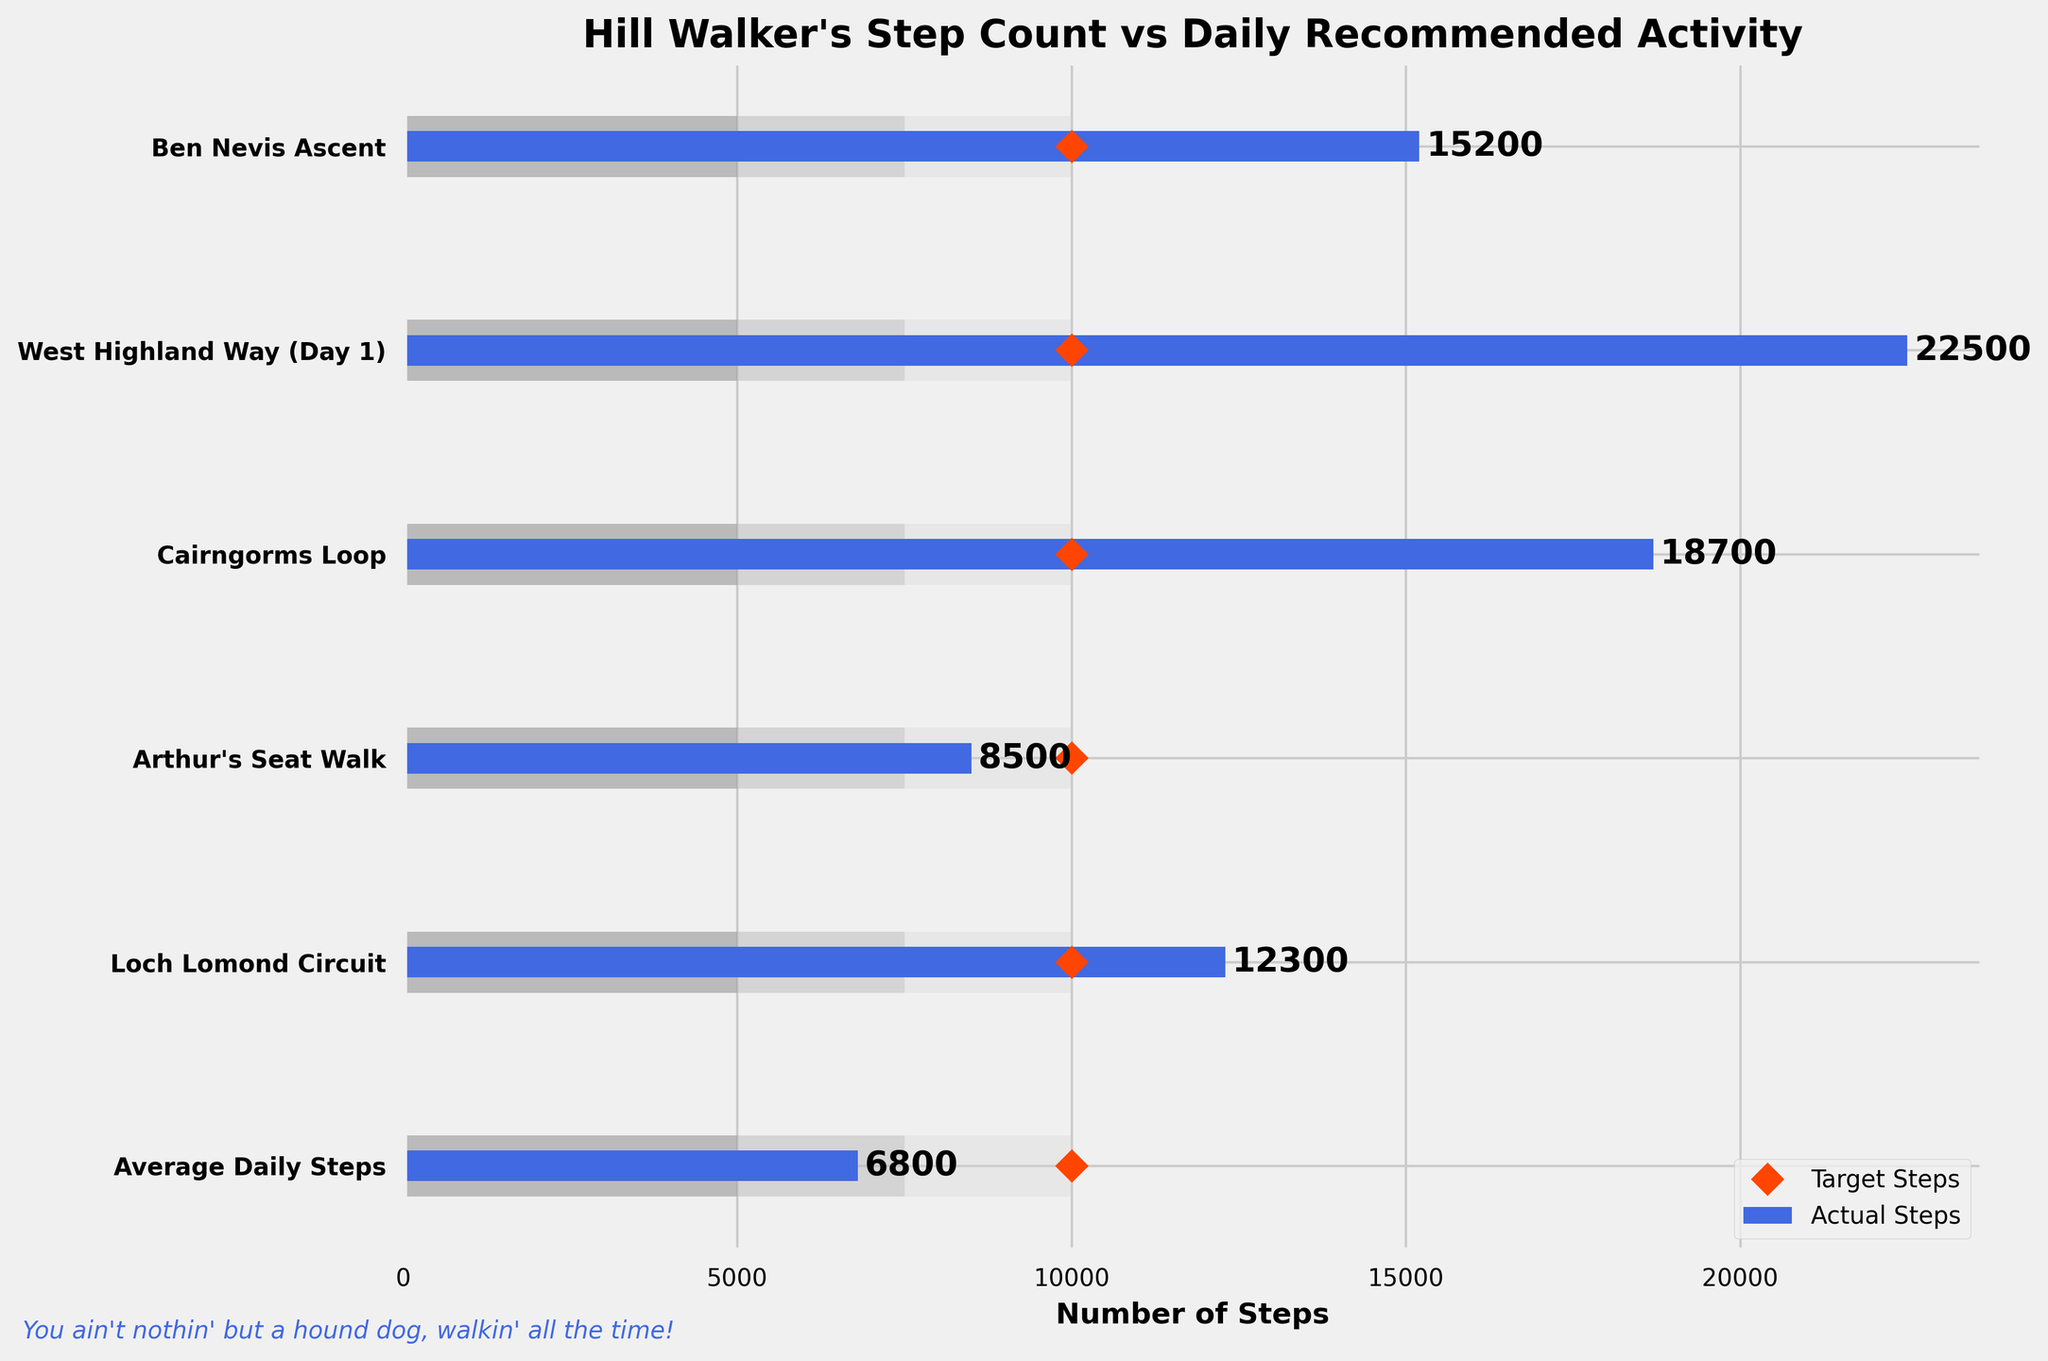What's the title of the figure? The title of the graph is typically at the top of the figure, displayed prominently in a larger and bold font for easy visibility. In this case, it is clearly written as "Hill Walker's Step Count vs Daily Recommended Activity".
Answer: Hill Walker's Step Count vs Daily Recommended Activity How many walks are compared in the figure? Each row in the figure represents a different walk or data point. We can count the number of rows to determine how many walks are included. Here, the figure has 6 rows corresponding to different walks.
Answer: 6 Which walk recorded the highest number of steps? By comparing the lengths of the blue bars (Actual Steps) across all walks, the walk with the longest blue bar represents the highest number of steps. "West Highland Way (Day 1)" has the longest blue bar.
Answer: West Highland Way (Day 1) Did "Arthur's Seat Walk" meet the target steps? To determine if the actual steps meet the target, we compare the length of the blue bar (Actual Steps) with the position of the orange diamond (Target Steps). For "Arthur's Seat Walk," the blue bar is shorter than the orange diamond, meaning it did not meet the target.
Answer: No How many walks exceeded the daily recommended target of 10,000 steps? We count the number of walks where the blue bar exceeds the position of the orange diamond. "Ben Nevis Ascent," "West Highland Way (Day 1)," "Cairngorms Loop," and "Loch Lomond Circuit" all exceed the target.
Answer: 4 What is the difference in steps between the "Ben Nevis Ascent" and the "Average Daily Steps"? Subtract the number of steps for "Average Daily Steps" from the number for "Ben Nevis Ascent": 15200 - 6800. Performing this calculation gives 8400 steps.
Answer: 8400 steps Which walk is closest to the target steps but still below it? To find the walk closest to the target but below it, look at the blue bars just shorter than the orange diamonds and identify the one with the smallest difference. "Arthur's Seat Walk" has 8500 steps, which is closest to 10,000 but still below the target.
Answer: Arthur's Seat Walk What is the average number of steps taken across all the walks except "Average Daily Steps"? Sum up the actual steps for all walks and divide by the number of walks: (15200 + 22500 + 18700 + 8500 + 12300) / 5. This calculates to an average of (15200 + 22500 + 18700 + 8500 + 12300) / 5 = 15440 steps.
Answer: 15440 steps Which walk(s) fall within the 'Fair' range of steps (7500-10000)? Walks within the 'Fair' range will have their blue bar lengths between 7500 and 10000 steps. "Arthur's Seat Walk" falls within this range with 8500 steps.
Answer: Arthur's Seat Walk Do any walks fall below the 'Poor' range of steps (below 5000)? By inspecting the blue bars to see if any are shorter than the first shaded range indicating 5000 steps, we see none of the walks fall below this threshold.
Answer: No 